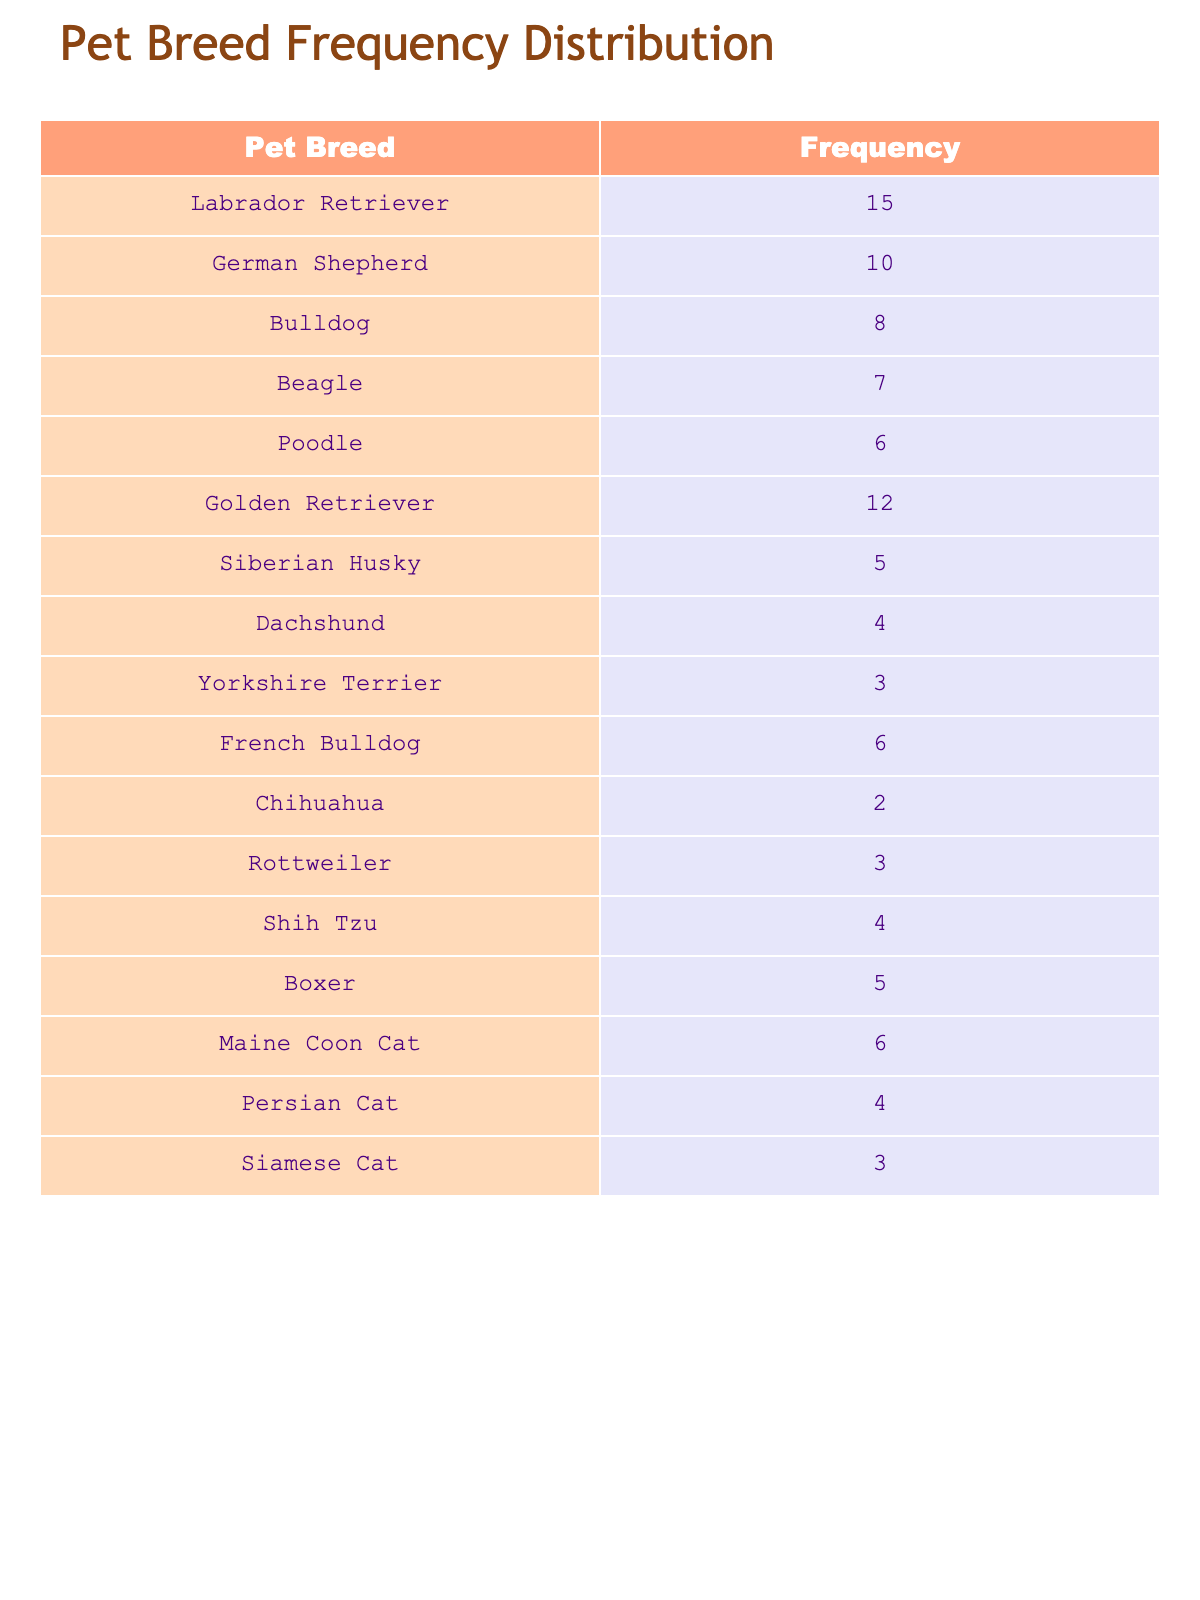What is the most frequently owned pet breed? The most frequently owned pet breed can be found by looking for the highest frequency value in the table. The Labrador Retriever has a frequency of 15, which is the highest compared to the others.
Answer: Labrador Retriever How many families own a Poodle? To find the number of families that own a Poodle, we can look directly in the table. The frequency for the Poodle is listed as 6.
Answer: 6 What is the total frequency of all pet breeds listed? To find the total frequency, we can sum all the frequency values in the table: 15 + 10 + 8 + 7 + 6 + 12 + 5 + 4 + 3 + 6 + 2 + 3 + 4 + 5 + 6 + 4 + 3 =  4 = 4 = 4 = 4 = 4. This gives us a total of 81.
Answer: 81 Is the Golden Retriever more commonly owned than the Beagle? To determine this, we compare their frequencies: the Golden Retriever has a frequency of 12, while the Beagle has a frequency of 7. Since 12 is greater than 7, we can conclude that the Golden Retriever is more commonly owned.
Answer: Yes Which pet breed is owned by the least number of families? To find the least owned pet breed, look for the lowest frequency in the table. The Chihuahua has a frequency of 2, which is the lowest among all the listed breeds.
Answer: Chihuahua What is the average frequency of the cat breeds listed? The frequencies for the cat breeds are: Maine Coon Cat (6), Persian Cat (4), and Siamese Cat (3). To compute the average, first sum the frequencies: 6 + 4 + 3 = 13. Then divide by the number of cat breeds: 13 / 3 = 4.33. Thus, the average frequency of the cat breeds is approximately 4.33.
Answer: 4.33 Are there more families owning Bulldogs than families owning Boxers? The Bulldog has a frequency of 8, while the Boxer has a frequency of 5. Since 8 is greater than 5, there are indeed more families owning Bulldogs.
Answer: Yes Which pet breed has a frequency that is exactly 5? We can look through the frequency values to find a breed that specifically has a frequency of 5. The pet breeds that meet this criterion are the Siberian Husky and the Boxer, both with a frequency of 5.
Answer: Siberian Husky, Boxer What is the difference in frequency between the top two pet breeds? The top pet breed is the Labrador Retriever with a frequency of 15, and the second is the Golden Retriever with a frequency of 12. The difference in frequency can be calculated as 15 - 12 = 3.
Answer: 3 